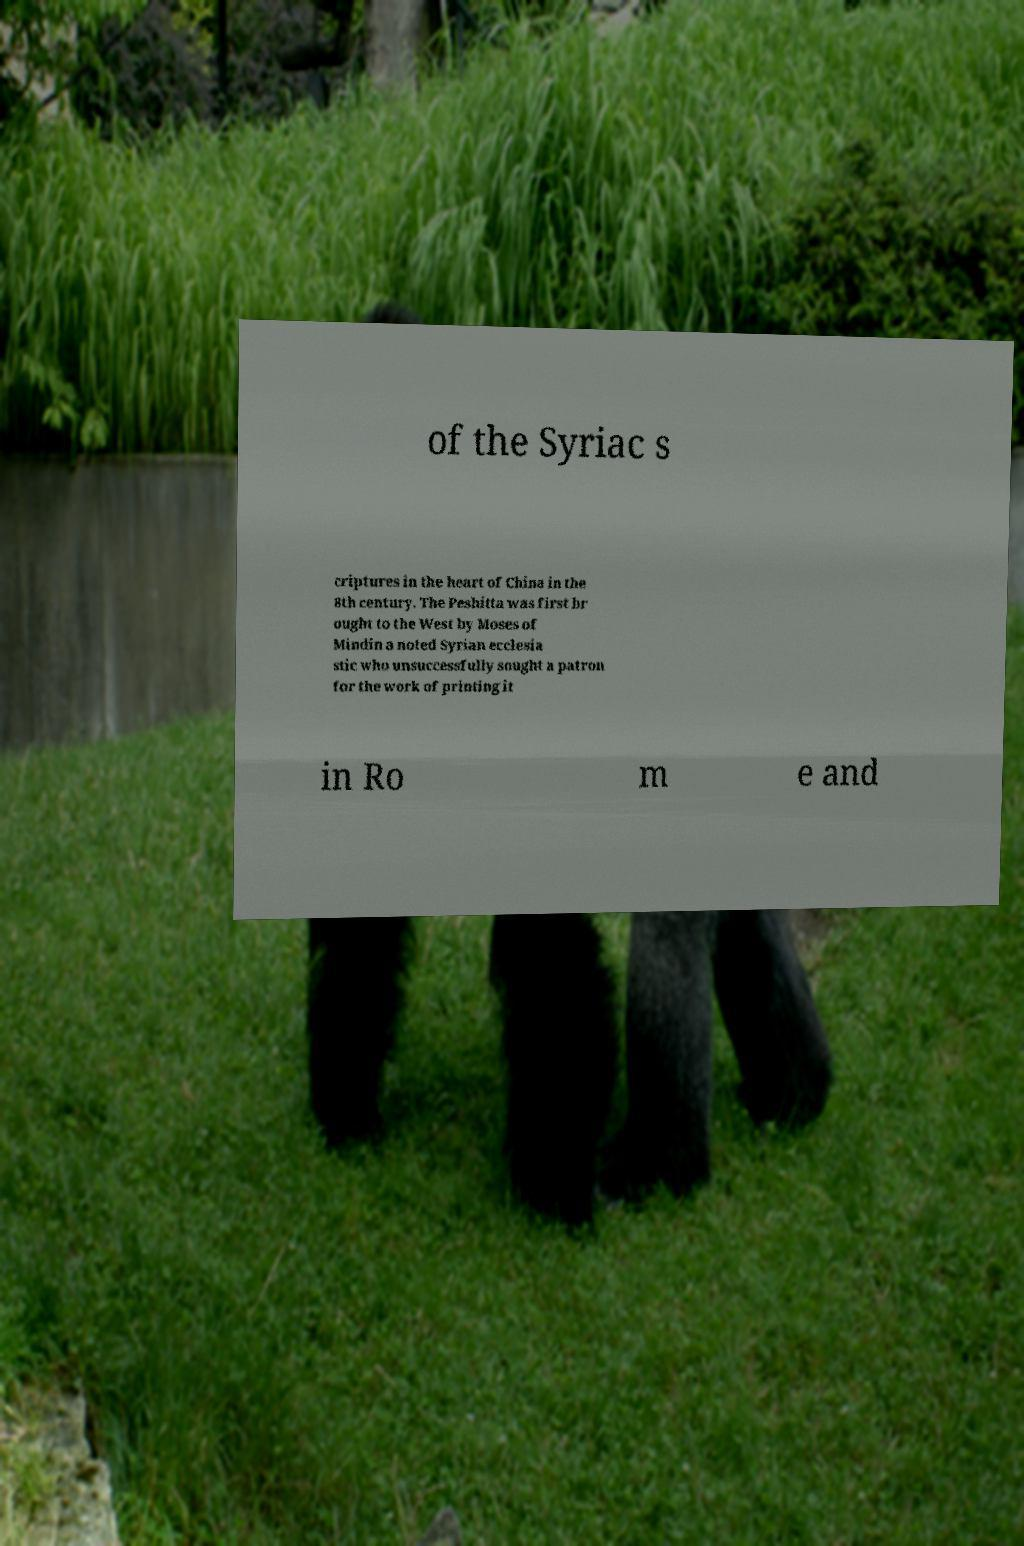Please identify and transcribe the text found in this image. of the Syriac s criptures in the heart of China in the 8th century. The Peshitta was first br ought to the West by Moses of Mindin a noted Syrian ecclesia stic who unsuccessfully sought a patron for the work of printing it in Ro m e and 